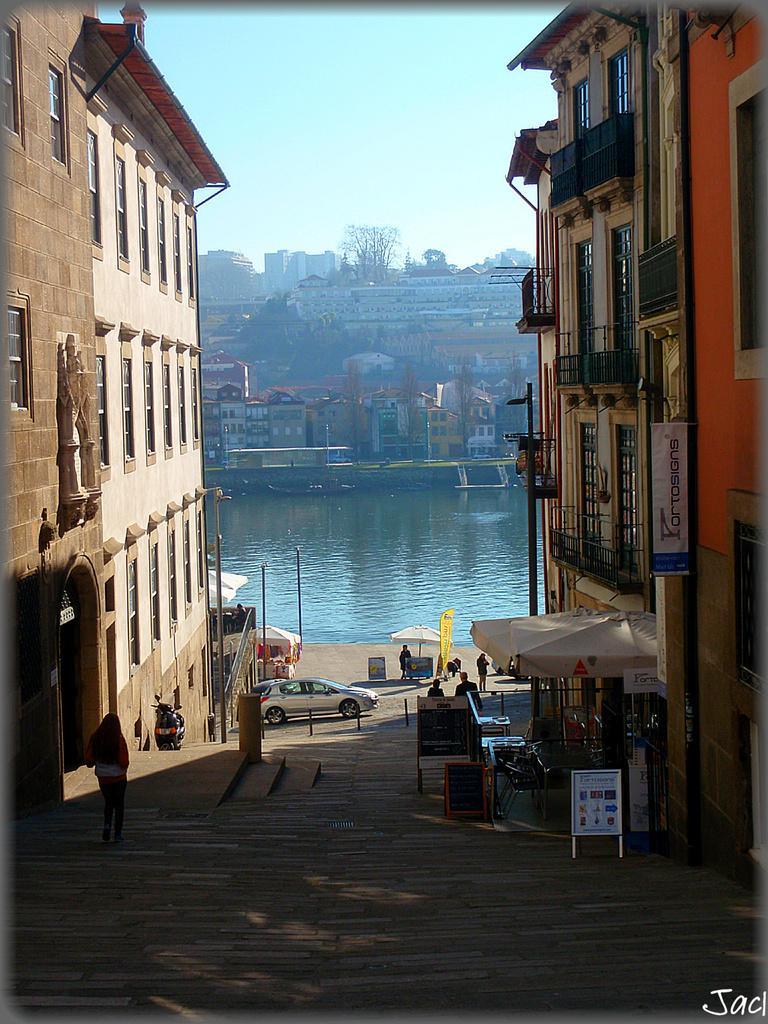Can you describe this image briefly? In this image I can see few people are standing in-front of the building. I can see the white color tent, boards and the vehicles can be seen in-front of the building. In the back I can see the water and there are many buildings to the side of the water. I can also see trees in the back. There is a blue color sky can be seen. 